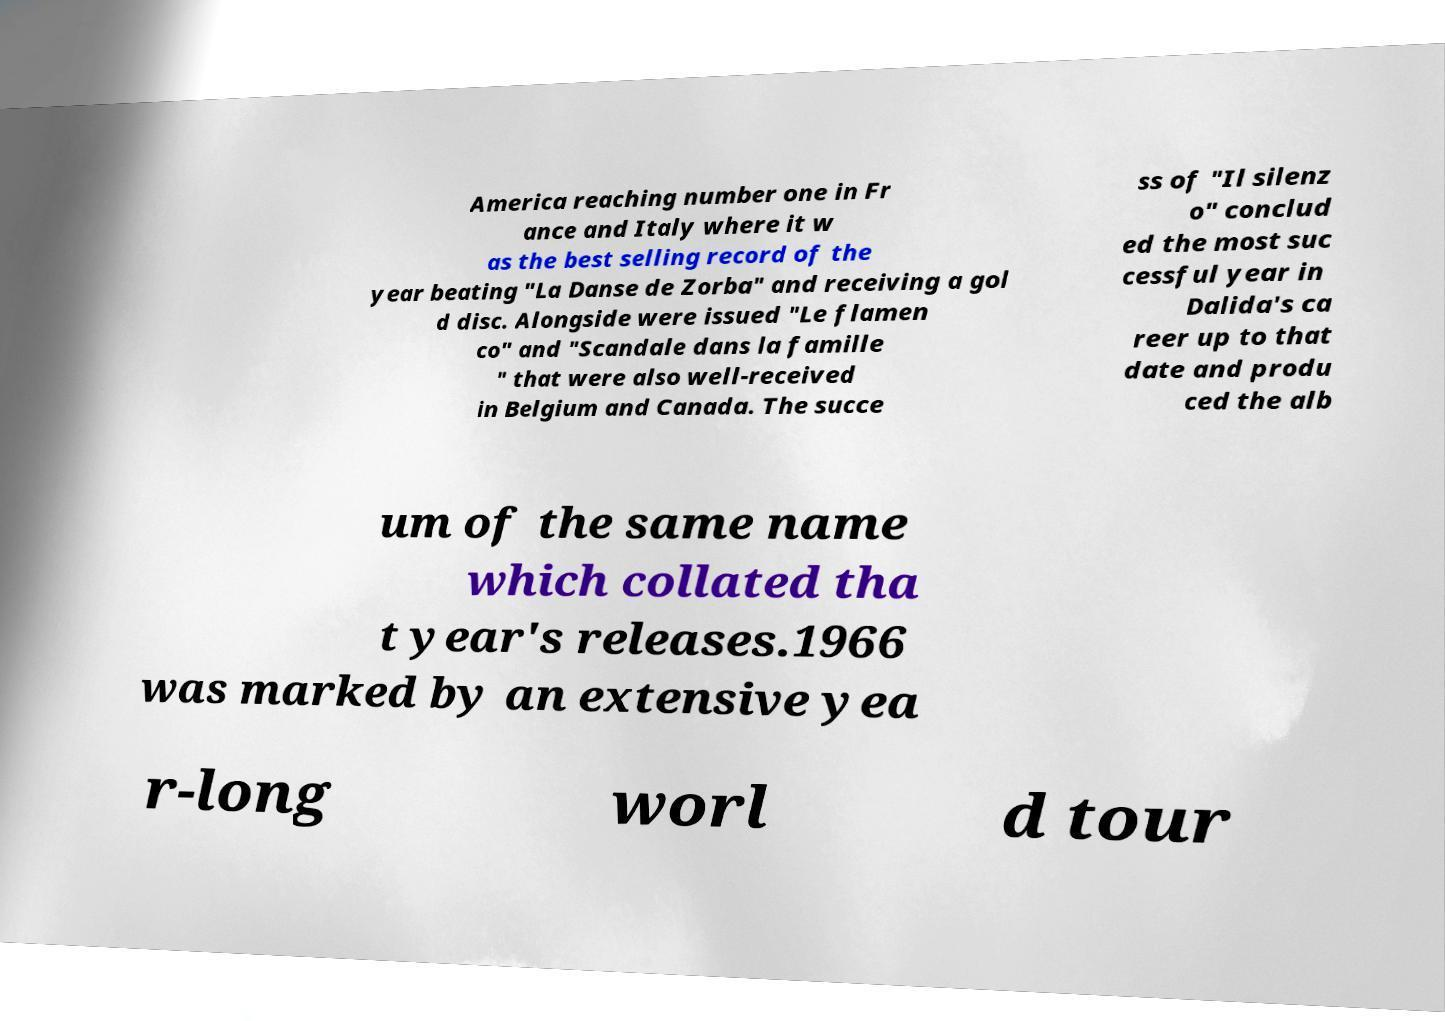Could you extract and type out the text from this image? America reaching number one in Fr ance and Italy where it w as the best selling record of the year beating "La Danse de Zorba" and receiving a gol d disc. Alongside were issued "Le flamen co" and "Scandale dans la famille " that were also well-received in Belgium and Canada. The succe ss of "Il silenz o" conclud ed the most suc cessful year in Dalida's ca reer up to that date and produ ced the alb um of the same name which collated tha t year's releases.1966 was marked by an extensive yea r-long worl d tour 